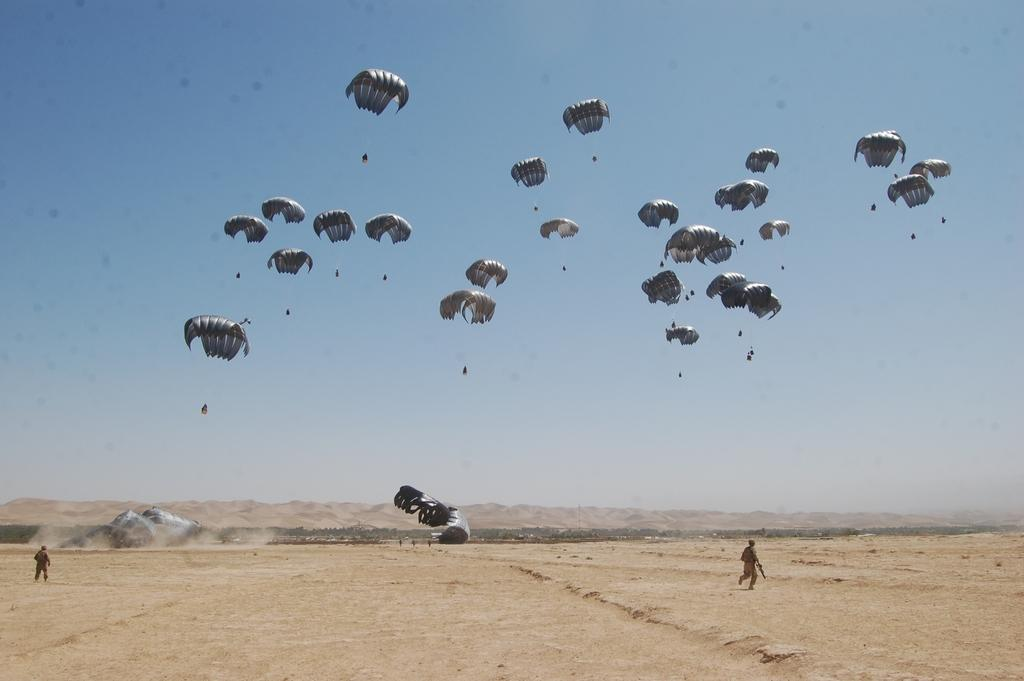What activity are the persons in the sky engaged in? The persons in the sky are doing paragliding. What are the persons on the ground doing? The persons on the ground are standing. What is the condition of the sky in the background? The sky in the background is clear. What type of window can be seen in the image? There is no window present in the image. What part of the paraglider is made of sheet material? The image does not provide enough detail to determine the materials used in the paraglider. 